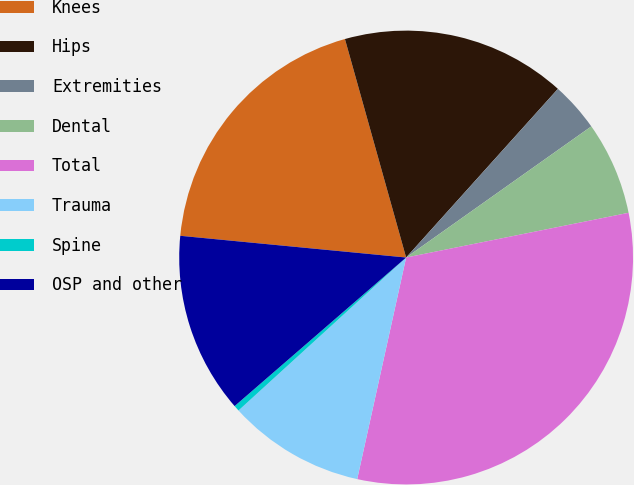<chart> <loc_0><loc_0><loc_500><loc_500><pie_chart><fcel>Knees<fcel>Hips<fcel>Extremities<fcel>Dental<fcel>Total<fcel>Trauma<fcel>Spine<fcel>OSP and other<nl><fcel>19.13%<fcel>16.01%<fcel>3.53%<fcel>6.65%<fcel>31.62%<fcel>9.77%<fcel>0.41%<fcel>12.89%<nl></chart> 